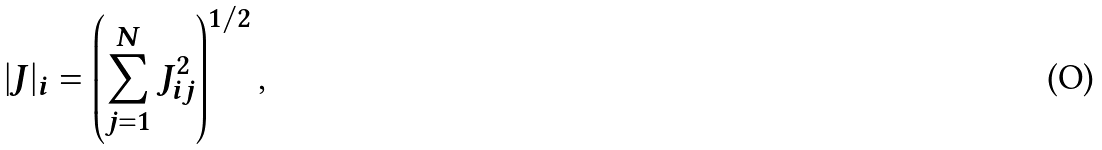<formula> <loc_0><loc_0><loc_500><loc_500>| J | _ { i } = \left ( \sum _ { j = 1 } ^ { N } J _ { i j } ^ { 2 } \right ) ^ { 1 / 2 } ,</formula> 